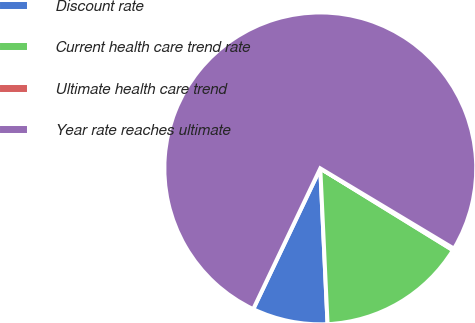Convert chart to OTSL. <chart><loc_0><loc_0><loc_500><loc_500><pie_chart><fcel>Discount rate<fcel>Current health care trend rate<fcel>Ultimate health care trend<fcel>Year rate reaches ultimate<nl><fcel>7.82%<fcel>15.46%<fcel>0.19%<fcel>76.53%<nl></chart> 